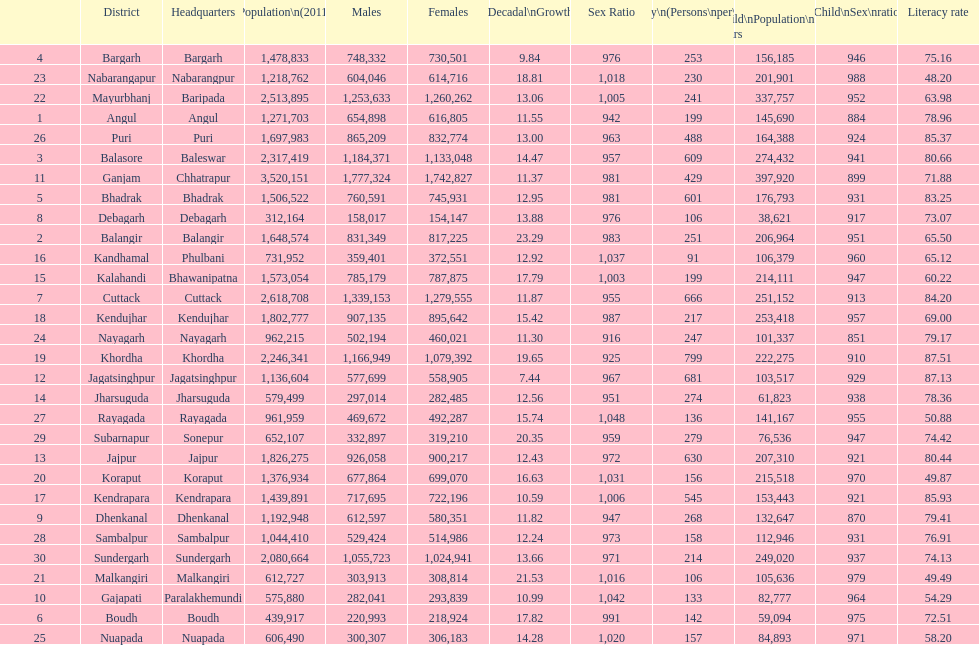What is the disparity in the number of children between koraput and puri? 51,130. 